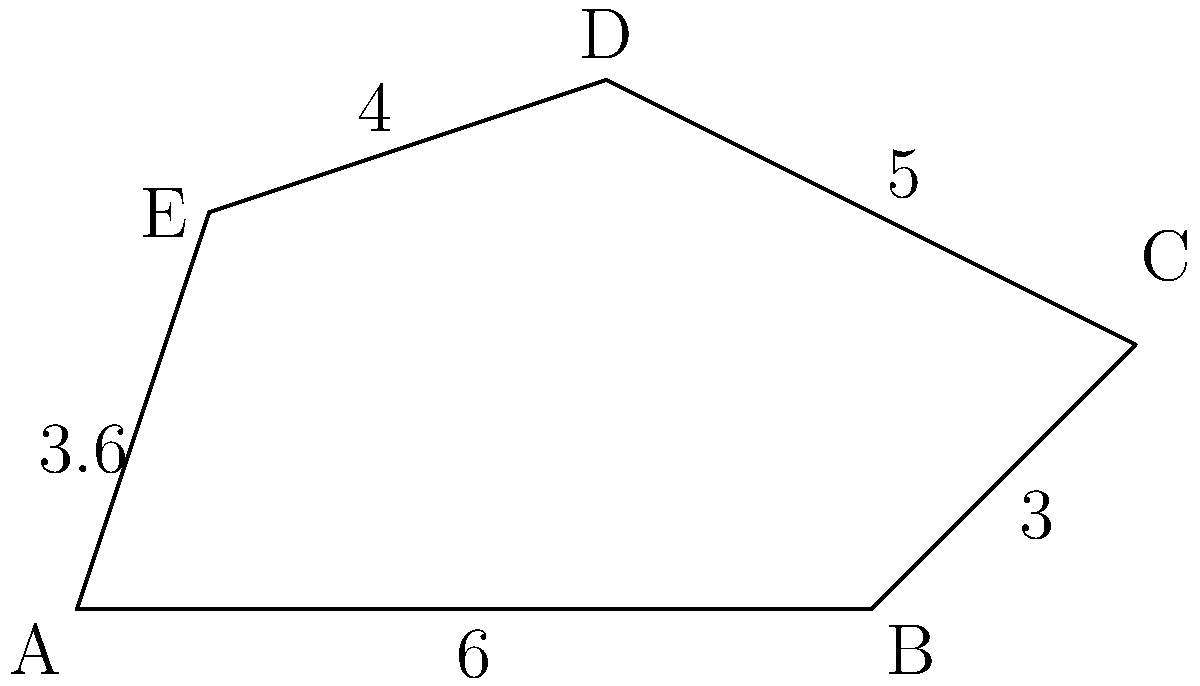In a Windows Server 2003 environment, network boundaries are represented by an irregular pentagon ABCDE. Given the side lengths AB = 6 units, BC = 3 units, CD = 5 units, DE = 4 units, and EA = 3.6 units, calculate the perimeter of this network boundary. How does this relate to potential security risks in an outdated server environment? To calculate the perimeter of the irregular pentagon ABCDE, we need to sum up the lengths of all sides:

1. Side AB = 6 units
2. Side BC = 3 units
3. Side CD = 5 units
4. Side DE = 4 units
5. Side EA = 3.6 units

Perimeter = AB + BC + CD + DE + EA
          = 6 + 3 + 5 + 4 + 3.6
          = 21.6 units

The perimeter of 21.6 units represents the total external boundary of the network. In the context of Windows Server 2003, an outdated and unsupported operating system, this perimeter symbolizes potential attack surfaces or vulnerabilities:

1. Each side of the pentagon can represent a different type of network connection or service.
2. The larger the perimeter, the more potential entry points for cyber attacks.
3. Windows Server 2003's lack of security updates makes each point on this perimeter more susceptible to exploitation.
4. The irregular shape suggests a complex network topology, which can be harder to secure and monitor effectively.
5. The outdated nature of Windows Server 2003 means that modern security measures may not be compatible or effective, leaving the entire perimeter at risk.

Understanding the "perimeter" of your network in an outdated server environment is crucial for identifying and mitigating potential security risks.
Answer: 21.6 units; larger perimeter in outdated systems increases attack surface 